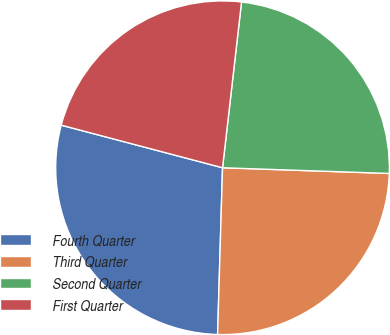Convert chart. <chart><loc_0><loc_0><loc_500><loc_500><pie_chart><fcel>Fourth Quarter<fcel>Third Quarter<fcel>Second Quarter<fcel>First Quarter<nl><fcel>28.64%<fcel>24.93%<fcel>23.73%<fcel>22.71%<nl></chart> 